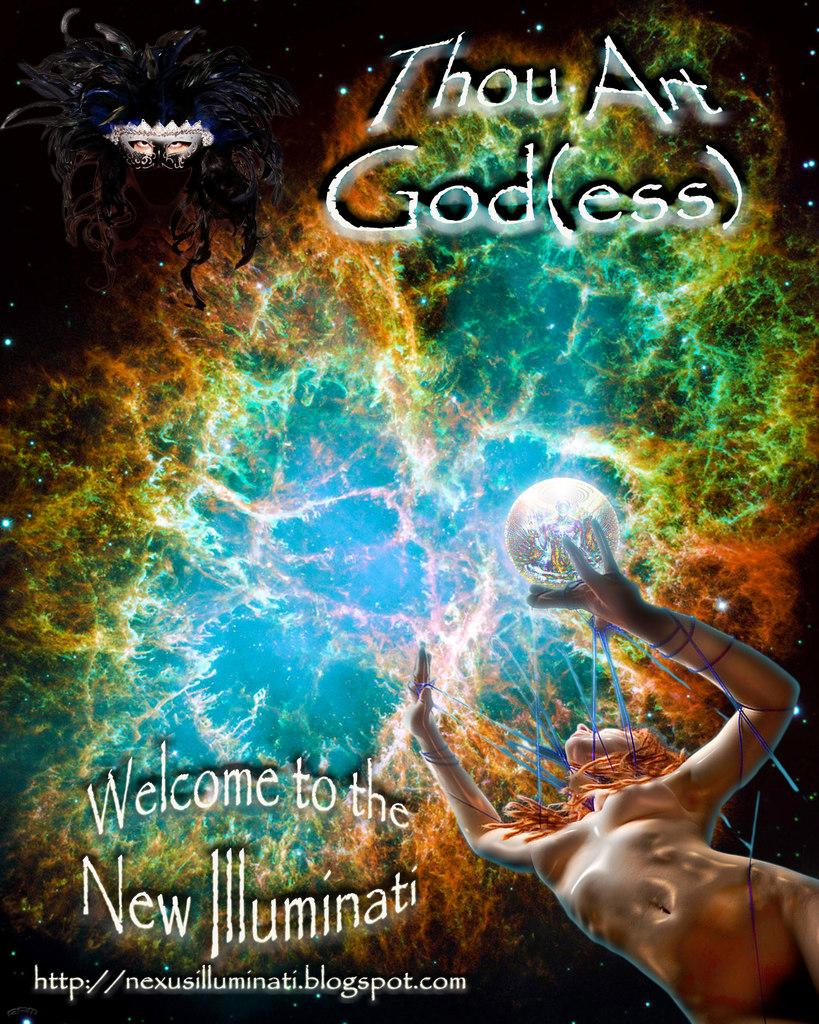What is present in the image that features an image of a girl? There is a poster in the image that contains an image of a girl. What else can be found on the poster besides the image of the girl? There is text on the poster. What is the opinion of the group regarding the business in the image? There is no group or business present in the image; it only features a poster with an image of a girl and text. 